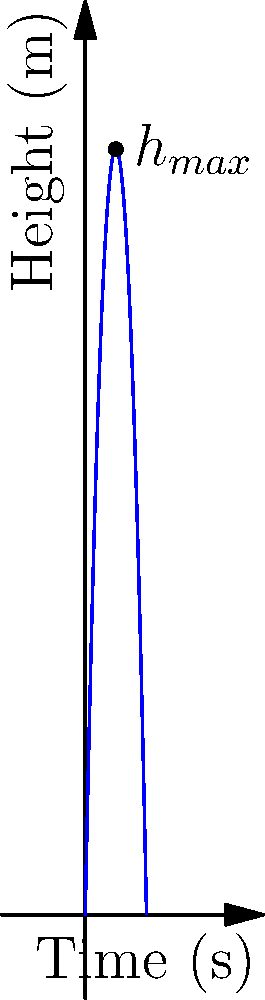A model rocket with a mass of 0.1 kg is launched vertically with an initial velocity of 50 m/s. Assuming air resistance is negligible, estimate the maximum altitude reached by the rocket. To solve this problem, we'll use the principles of projectile motion under constant acceleration (gravity). Here's a step-by-step approach:

1) The equation for the height of the rocket as a function of time is:
   $$h(t) = v_0t - \frac{1}{2}gt^2$$
   where $v_0$ is the initial velocity, $g$ is the acceleration due to gravity, and $t$ is time.

2) The rocket reaches its maximum height when its vertical velocity becomes zero. We can find this time by setting the derivative of $h(t)$ to zero:
   $$\frac{dh}{dt} = v_0 - gt = 0$$

3) Solving for $t$:
   $$t_{max} = \frac{v_0}{g} = \frac{50 \text{ m/s}}{9.8 \text{ m/s}^2} = 5.1 \text{ s}$$

4) Now we can substitute this time back into the original equation to find the maximum height:
   $$h_{max} = v_0t_{max} - \frac{1}{2}gt_{max}^2$$
   $$h_{max} = 50 \text{ m/s} \cdot 5.1 \text{ s} - \frac{1}{2} \cdot 9.8 \text{ m/s}^2 \cdot (5.1 \text{ s})^2$$

5) Calculating:
   $$h_{max} = 255 \text{ m} - 127.5 \text{ m} = 127.5 \text{ m}$$

Therefore, the maximum altitude reached by the rocket is approximately 127.5 meters.
Answer: 127.5 m 